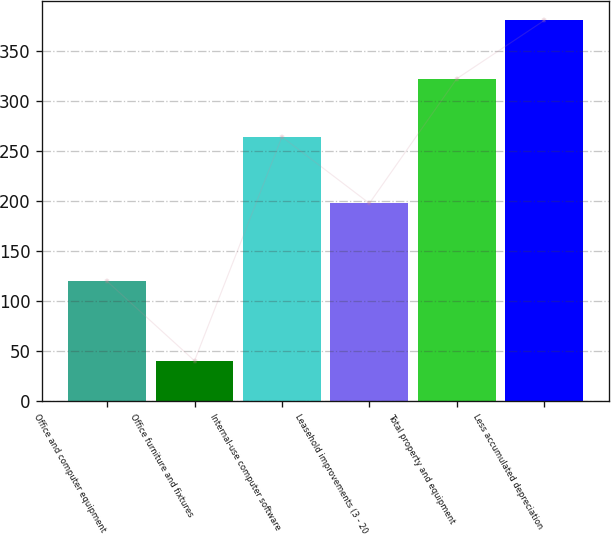<chart> <loc_0><loc_0><loc_500><loc_500><bar_chart><fcel>Office and computer equipment<fcel>Office furniture and fixtures<fcel>Internal-use computer software<fcel>Leasehold improvements (3 - 20<fcel>Total property and equipment<fcel>Less accumulated depreciation<nl><fcel>119.7<fcel>40.3<fcel>263.9<fcel>197.5<fcel>322.01<fcel>380.12<nl></chart> 